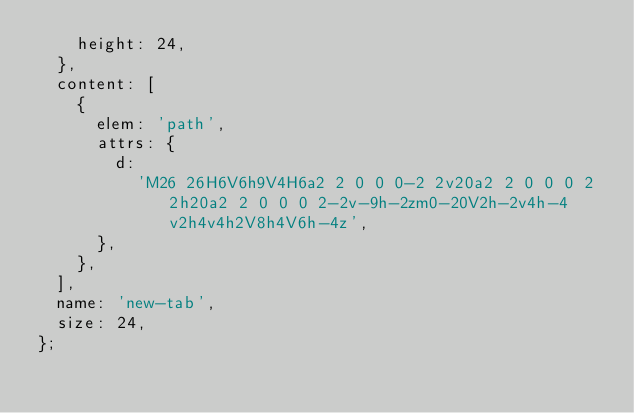<code> <loc_0><loc_0><loc_500><loc_500><_JavaScript_>    height: 24,
  },
  content: [
    {
      elem: 'path',
      attrs: {
        d:
          'M26 26H6V6h9V4H6a2 2 0 0 0-2 2v20a2 2 0 0 0 2 2h20a2 2 0 0 0 2-2v-9h-2zm0-20V2h-2v4h-4v2h4v4h2V8h4V6h-4z',
      },
    },
  ],
  name: 'new-tab',
  size: 24,
};
</code> 